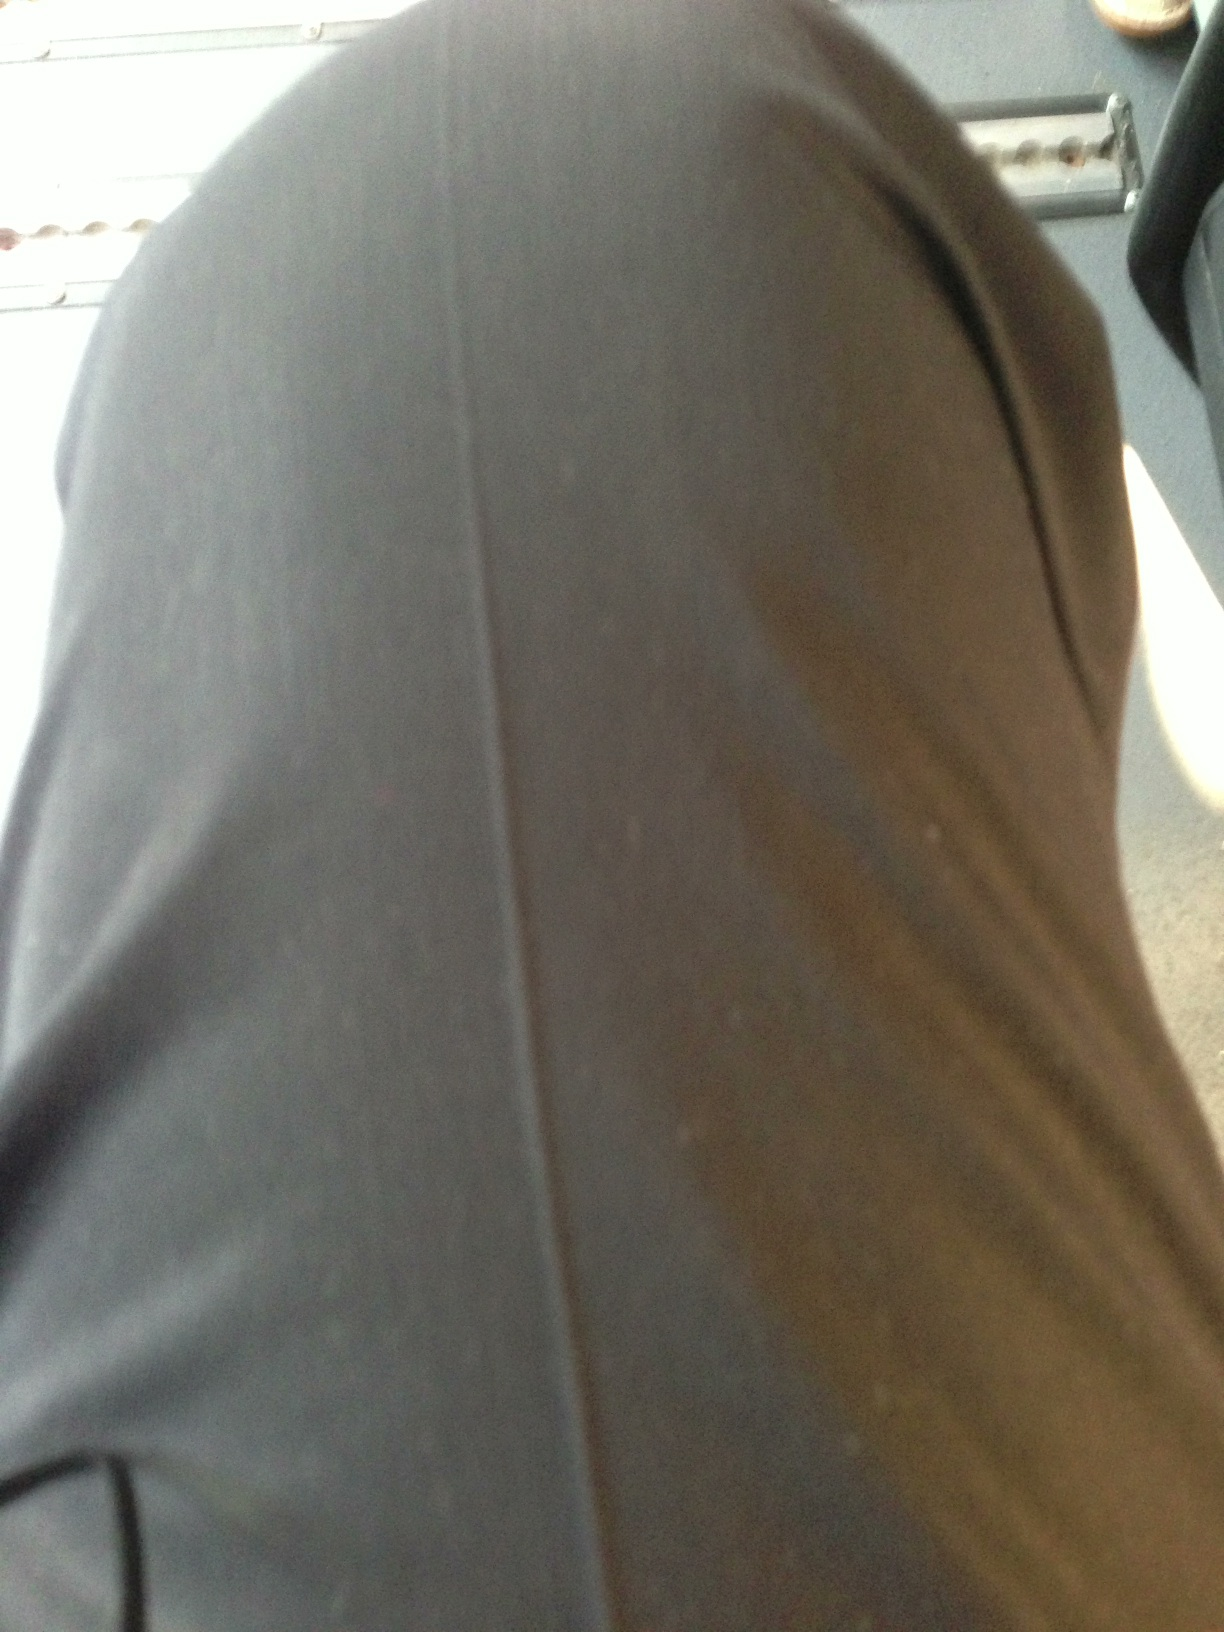Are these pants suitable for formal or casual wear? These dark grey pants could be versatile in a wardrobe. Depending on the accompanying attire, they can be dressed up for a formal setting with a smart shirt and blazer, or dressed down for a more casual look with a t-shirt or sweater. 